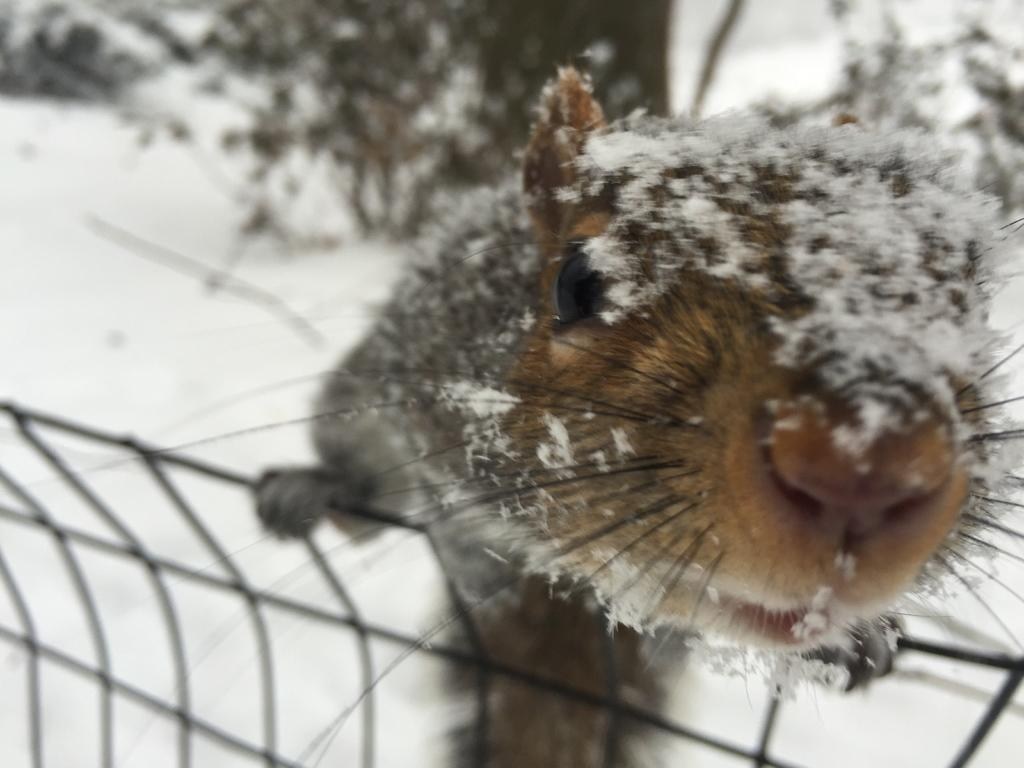What type of animal is present in the image? There is a mouse in the image. What is the weather or season suggested by the image? There is snow in the image, which suggests a cold or wintery setting. What type of cherry can be seen growing on the bushes in the image? There are no bushes or cherries present in the image; it features a mouse and snow. How many mittens can be seen in the image? There are no mittens present in the image. 